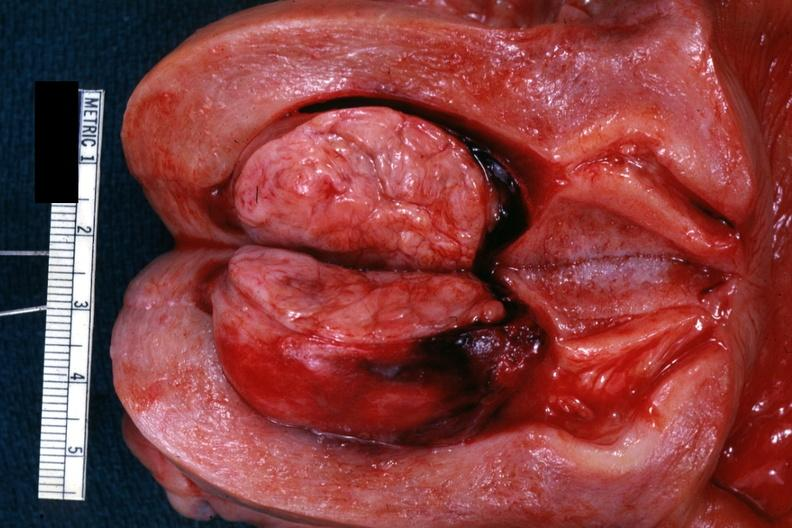does sacrococcygeal teratoma show excellent example of submucosal?
Answer the question using a single word or phrase. No 